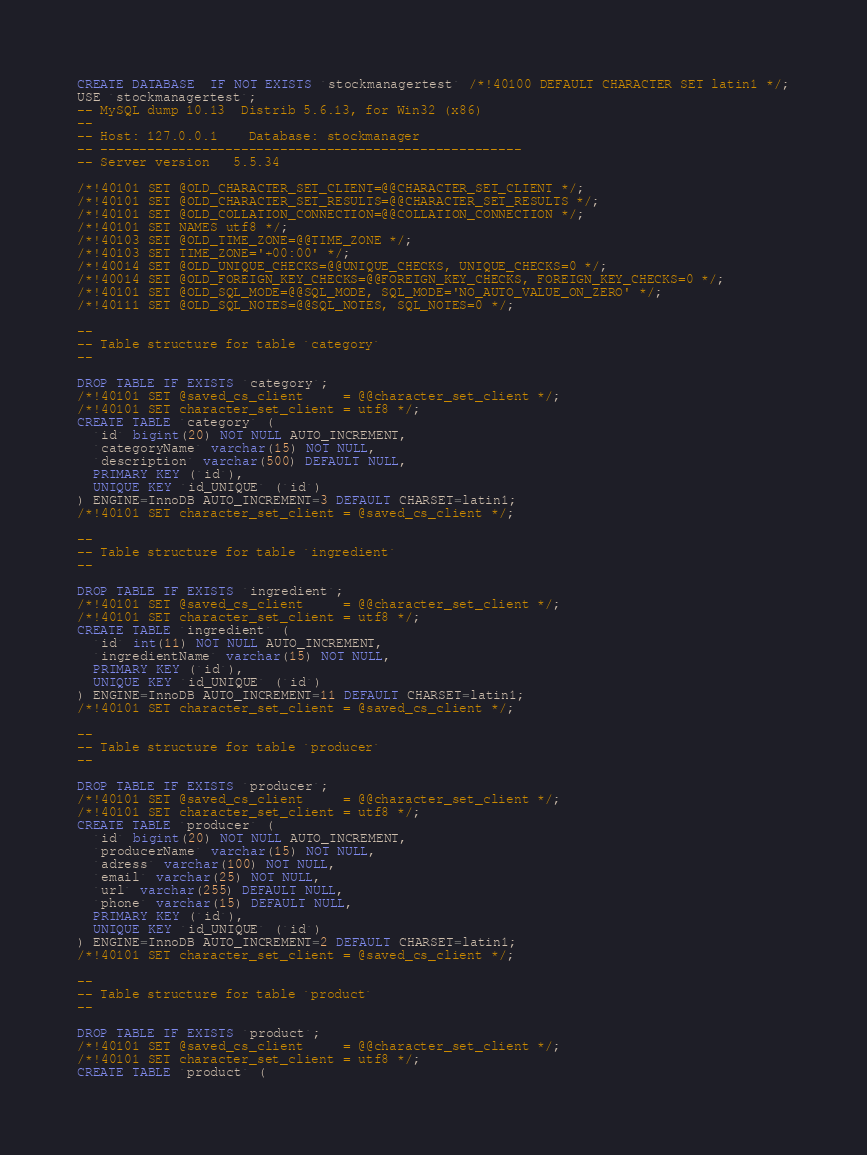<code> <loc_0><loc_0><loc_500><loc_500><_SQL_>CREATE DATABASE  IF NOT EXISTS `stockmanagertest` /*!40100 DEFAULT CHARACTER SET latin1 */;
USE `stockmanagertest`;
-- MySQL dump 10.13  Distrib 5.6.13, for Win32 (x86)
--
-- Host: 127.0.0.1    Database: stockmanager
-- ------------------------------------------------------
-- Server version	5.5.34

/*!40101 SET @OLD_CHARACTER_SET_CLIENT=@@CHARACTER_SET_CLIENT */;
/*!40101 SET @OLD_CHARACTER_SET_RESULTS=@@CHARACTER_SET_RESULTS */;
/*!40101 SET @OLD_COLLATION_CONNECTION=@@COLLATION_CONNECTION */;
/*!40101 SET NAMES utf8 */;
/*!40103 SET @OLD_TIME_ZONE=@@TIME_ZONE */;
/*!40103 SET TIME_ZONE='+00:00' */;
/*!40014 SET @OLD_UNIQUE_CHECKS=@@UNIQUE_CHECKS, UNIQUE_CHECKS=0 */;
/*!40014 SET @OLD_FOREIGN_KEY_CHECKS=@@FOREIGN_KEY_CHECKS, FOREIGN_KEY_CHECKS=0 */;
/*!40101 SET @OLD_SQL_MODE=@@SQL_MODE, SQL_MODE='NO_AUTO_VALUE_ON_ZERO' */;
/*!40111 SET @OLD_SQL_NOTES=@@SQL_NOTES, SQL_NOTES=0 */;

--
-- Table structure for table `category`
--

DROP TABLE IF EXISTS `category`;
/*!40101 SET @saved_cs_client     = @@character_set_client */;
/*!40101 SET character_set_client = utf8 */;
CREATE TABLE `category` (
  `id` bigint(20) NOT NULL AUTO_INCREMENT,
  `categoryName` varchar(15) NOT NULL,
  `description` varchar(500) DEFAULT NULL,
  PRIMARY KEY (`id`),
  UNIQUE KEY `id_UNIQUE` (`id`)
) ENGINE=InnoDB AUTO_INCREMENT=3 DEFAULT CHARSET=latin1;
/*!40101 SET character_set_client = @saved_cs_client */;

--
-- Table structure for table `ingredient`
--

DROP TABLE IF EXISTS `ingredient`;
/*!40101 SET @saved_cs_client     = @@character_set_client */;
/*!40101 SET character_set_client = utf8 */;
CREATE TABLE `ingredient` (
  `id` int(11) NOT NULL AUTO_INCREMENT,
  `ingredientName` varchar(15) NOT NULL,
  PRIMARY KEY (`id`),
  UNIQUE KEY `id_UNIQUE` (`id`)
) ENGINE=InnoDB AUTO_INCREMENT=11 DEFAULT CHARSET=latin1;
/*!40101 SET character_set_client = @saved_cs_client */;

--
-- Table structure for table `producer`
--

DROP TABLE IF EXISTS `producer`;
/*!40101 SET @saved_cs_client     = @@character_set_client */;
/*!40101 SET character_set_client = utf8 */;
CREATE TABLE `producer` (
  `id` bigint(20) NOT NULL AUTO_INCREMENT,
  `producerName` varchar(15) NOT NULL,
  `adress` varchar(100) NOT NULL,
  `email` varchar(25) NOT NULL,
  `url` varchar(255) DEFAULT NULL,
  `phone` varchar(15) DEFAULT NULL,
  PRIMARY KEY (`id`),
  UNIQUE KEY `id_UNIQUE` (`id`)
) ENGINE=InnoDB AUTO_INCREMENT=2 DEFAULT CHARSET=latin1;
/*!40101 SET character_set_client = @saved_cs_client */;

--
-- Table structure for table `product`
--

DROP TABLE IF EXISTS `product`;
/*!40101 SET @saved_cs_client     = @@character_set_client */;
/*!40101 SET character_set_client = utf8 */;
CREATE TABLE `product` (</code> 